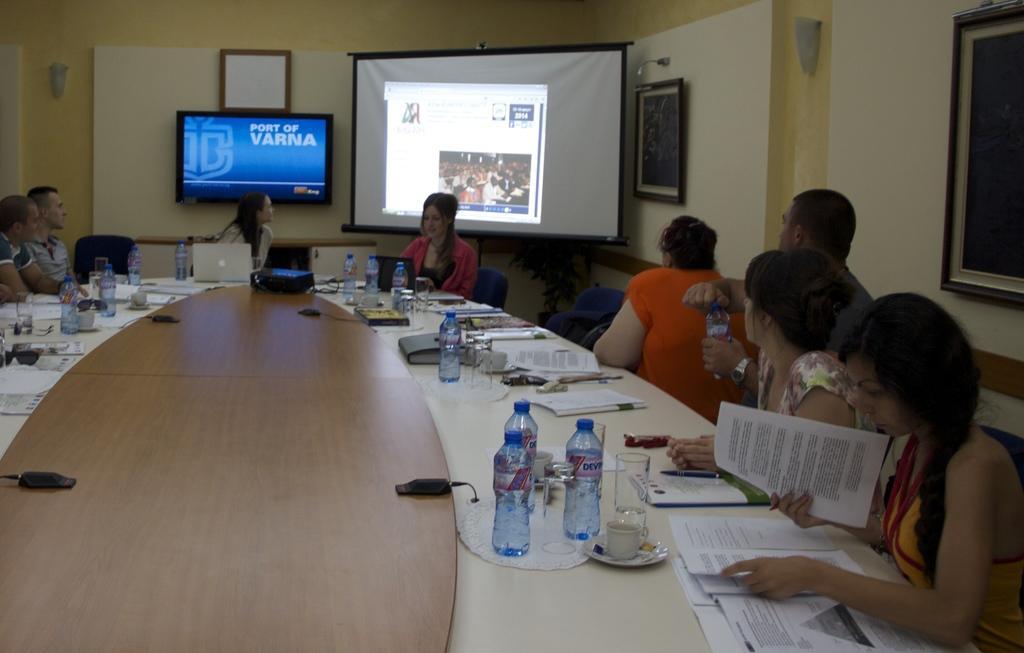Can you describe this image briefly? this picture shows people seated on a chair and a projector screen and a television and we see papers, water bottles , laptop on the table 